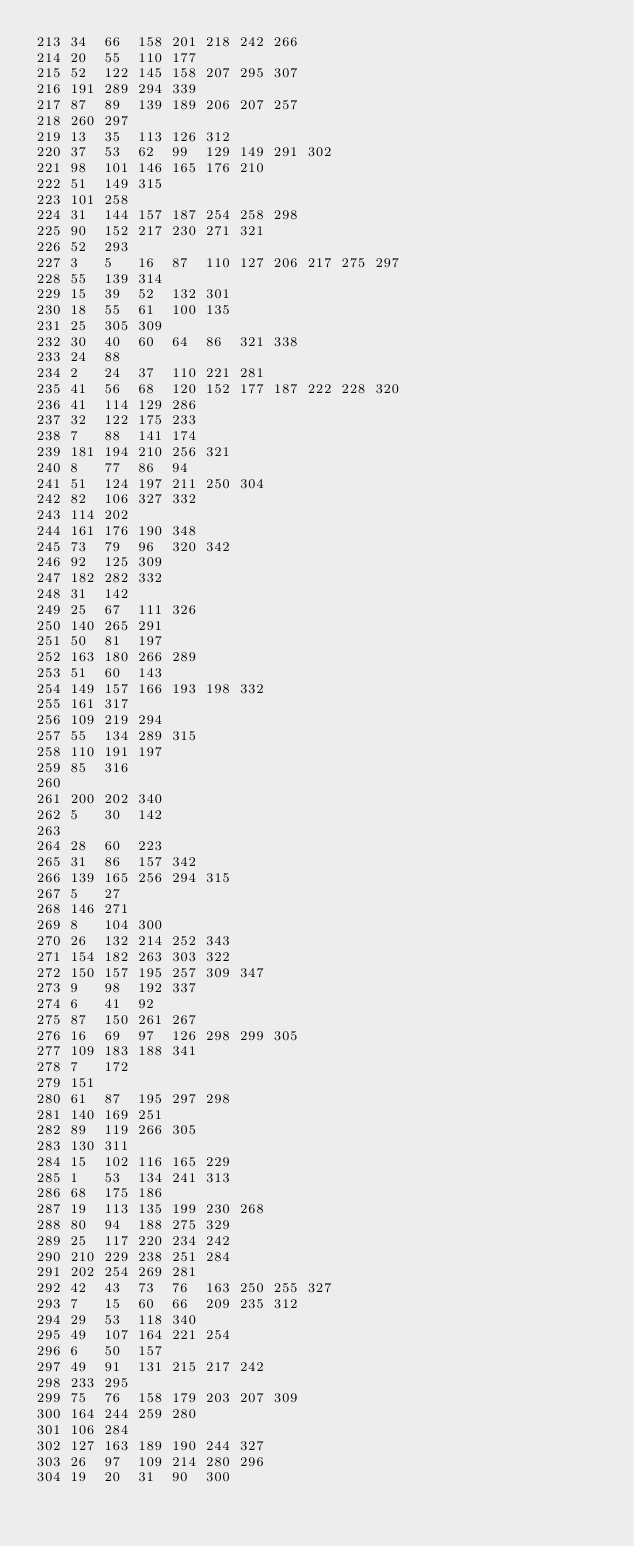<code> <loc_0><loc_0><loc_500><loc_500><_Perl_>213	34	66	158	201	218	242	266
214	20	55	110	177
215	52	122	145	158	207	295	307
216	191	289	294	339
217	87	89	139	189	206	207	257
218	260	297
219	13	35	113	126	312
220	37	53	62	99	129	149	291	302
221	98	101	146	165	176	210
222	51	149	315
223	101	258
224	31	144	157	187	254	258	298
225	90	152	217	230	271	321
226	52	293
227	3	5	16	87	110	127	206	217	275	297
228	55	139	314
229	15	39	52	132	301
230	18	55	61	100	135
231	25	305	309
232	30	40	60	64	86	321	338
233	24	88
234	2	24	37	110	221	281
235	41	56	68	120	152	177	187	222	228	320
236	41	114	129	286
237	32	122	175	233
238	7	88	141	174
239	181	194	210	256	321
240	8	77	86	94
241	51	124	197	211	250	304
242	82	106	327	332
243	114	202
244	161	176	190	348
245	73	79	96	320	342
246	92	125	309
247	182	282	332
248	31	142
249	25	67	111	326
250	140	265	291
251	50	81	197
252	163	180	266	289
253	51	60	143
254	149	157	166	193	198	332
255	161	317
256	109	219	294
257	55	134	289	315
258	110	191	197
259	85	316
260
261	200	202	340
262	5	30	142
263
264	28	60	223
265	31	86	157	342
266	139	165	256	294	315
267	5	27
268	146	271
269	8	104	300
270	26	132	214	252	343
271	154	182	263	303	322
272	150	157	195	257	309	347
273	9	98	192	337
274	6	41	92
275	87	150	261	267
276	16	69	97	126	298	299	305
277	109	183	188	341
278	7	172
279	151
280	61	87	195	297	298
281	140	169	251
282	89	119	266	305
283	130	311
284	15	102	116	165	229
285	1	53	134	241	313
286	68	175	186
287	19	113	135	199	230	268
288	80	94	188	275	329
289	25	117	220	234	242
290	210	229	238	251	284
291	202	254	269	281
292	42	43	73	76	163	250	255	327
293	7	15	60	66	209	235	312
294	29	53	118	340
295	49	107	164	221	254
296	6	50	157
297	49	91	131	215	217	242
298	233	295
299	75	76	158	179	203	207	309
300	164	244	259	280
301	106	284
302	127	163	189	190	244	327
303	26	97	109	214	280	296
304	19	20	31	90	300</code> 